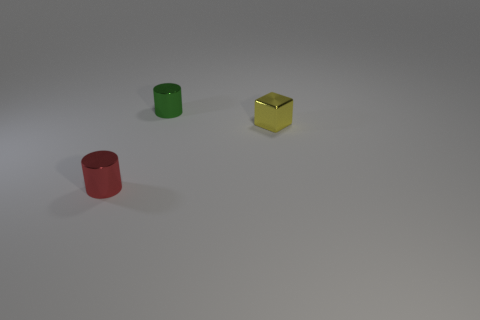Add 1 red metallic cylinders. How many objects exist? 4 Subtract all blocks. How many objects are left? 2 Subtract all tiny green cylinders. Subtract all large cyan rubber cylinders. How many objects are left? 2 Add 3 shiny cylinders. How many shiny cylinders are left? 5 Add 2 green rubber objects. How many green rubber objects exist? 2 Subtract 0 blue cubes. How many objects are left? 3 